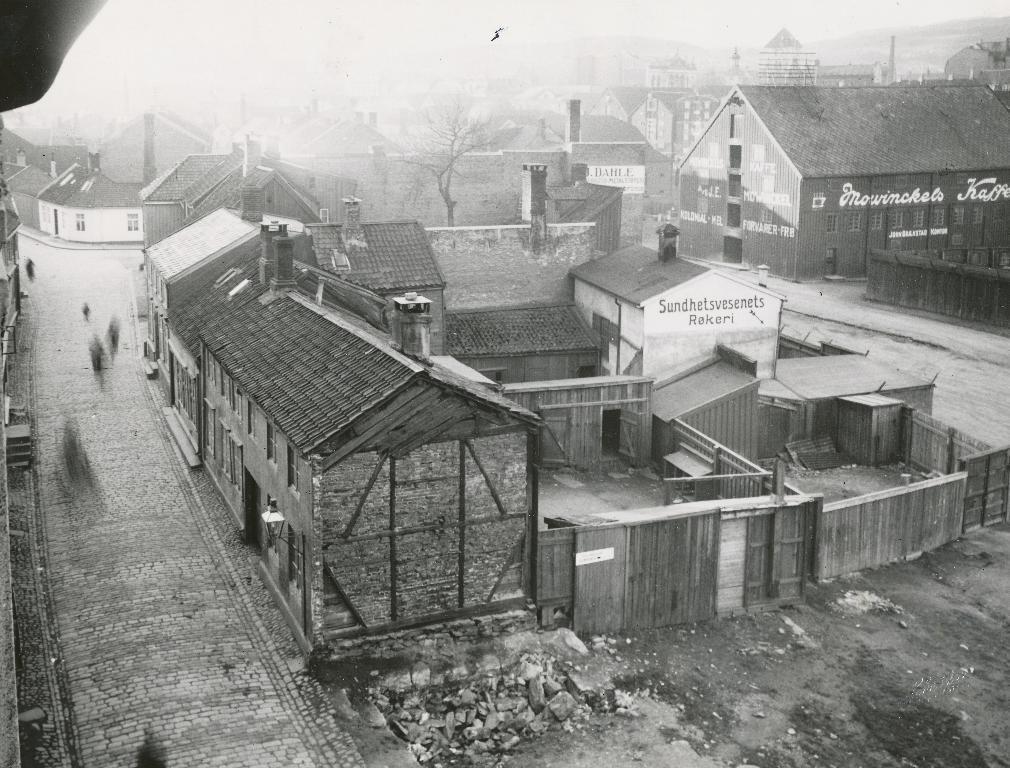Can you describe this image briefly? This is a black and white picture. Here we can see houses, boards, and trees. 